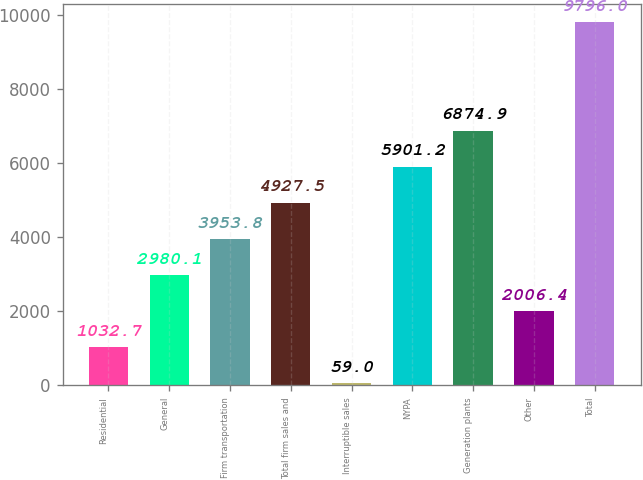Convert chart to OTSL. <chart><loc_0><loc_0><loc_500><loc_500><bar_chart><fcel>Residential<fcel>General<fcel>Firm transportation<fcel>Total firm sales and<fcel>Interruptible sales<fcel>NYPA<fcel>Generation plants<fcel>Other<fcel>Total<nl><fcel>1032.7<fcel>2980.1<fcel>3953.8<fcel>4927.5<fcel>59<fcel>5901.2<fcel>6874.9<fcel>2006.4<fcel>9796<nl></chart> 